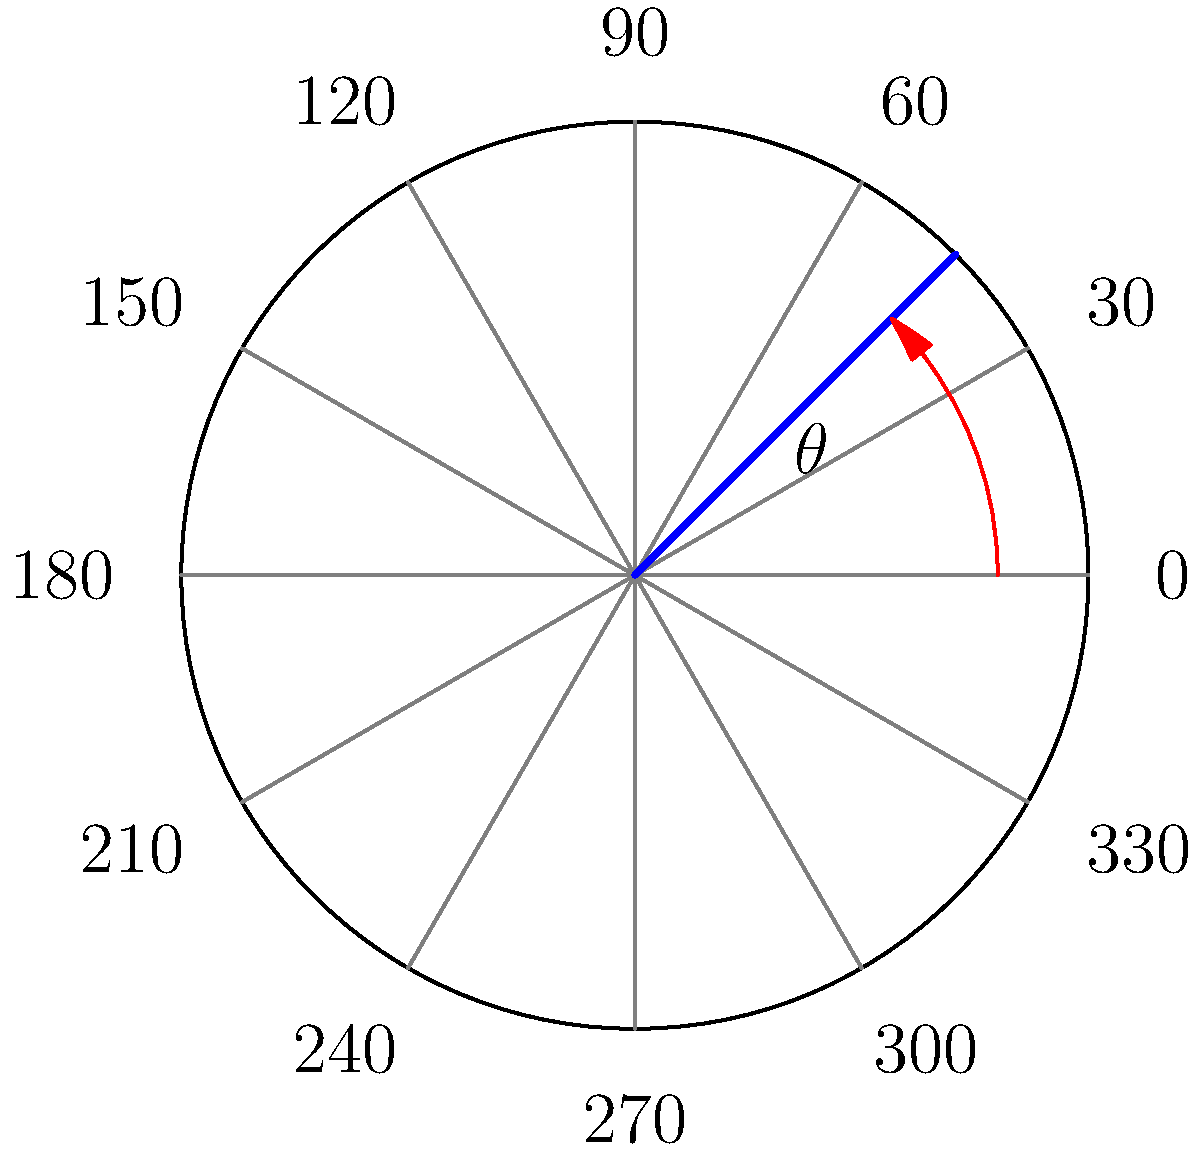A robotic arm's joint angle is measured using a circular protractor as shown in the diagram. The arm has rotated from its initial position at 0° to the blue line. What is the angle of rotation $\theta$ in degrees? To determine the angle of rotation $\theta$, we need to follow these steps:

1. Identify the initial position (0°) and the final position (blue line) of the robotic arm.

2. Observe that the protractor is marked in 30° increments.

3. Count the number of 30° increments between 0° and the blue line:
   - We can see that the blue line falls between 30° and 60°.

4. Estimate the position of the blue line more precisely:
   - The blue line appears to be halfway between 30° and 60°.
   - Halfway between 30° and 60° is 45°.

5. Therefore, the angle of rotation $\theta$ is 45°.

In robotic simulations using ROS and Gazebo, this angle would typically be converted to radians ($\frac{\pi}{4}$ radians) for use in calculations and control algorithms.
Answer: $45°$ 